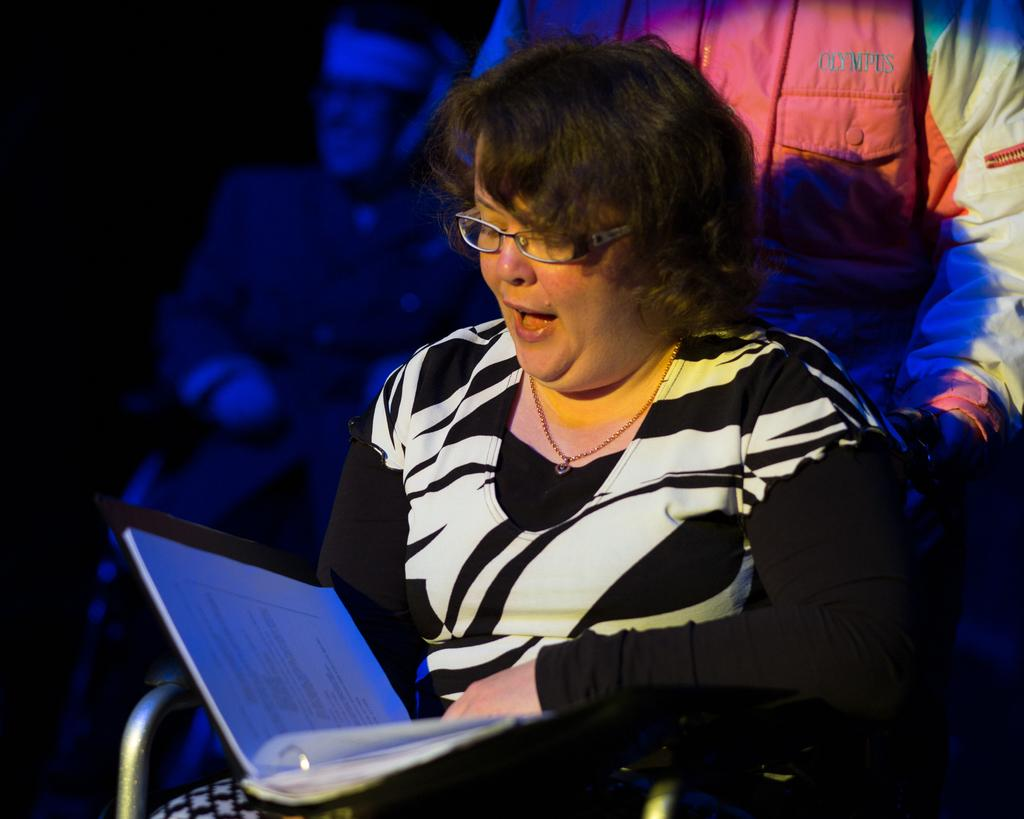Who is the main subject in the image? There is a lady in the image. What is the lady doing in the image? The lady is sitting on a chair and reading a book. Can you describe the background of the image? The background appears to be dark, and there are people visible in the background. What type of brush is the lady using to paint the rainstorm in the image? There is no brush or rainstorm present in the image; the lady is reading a book. 